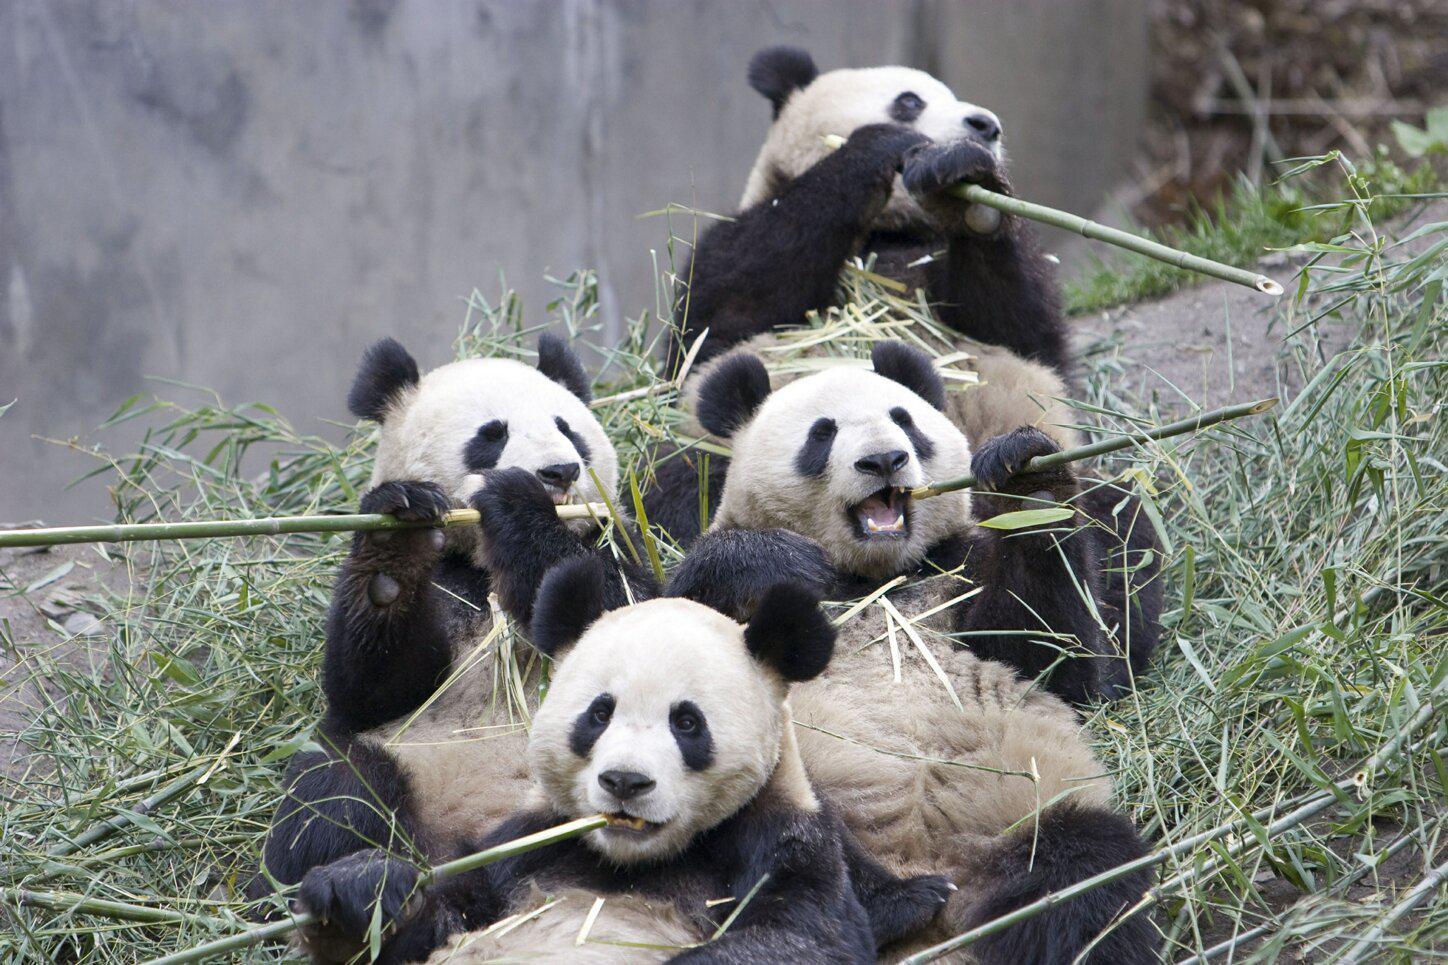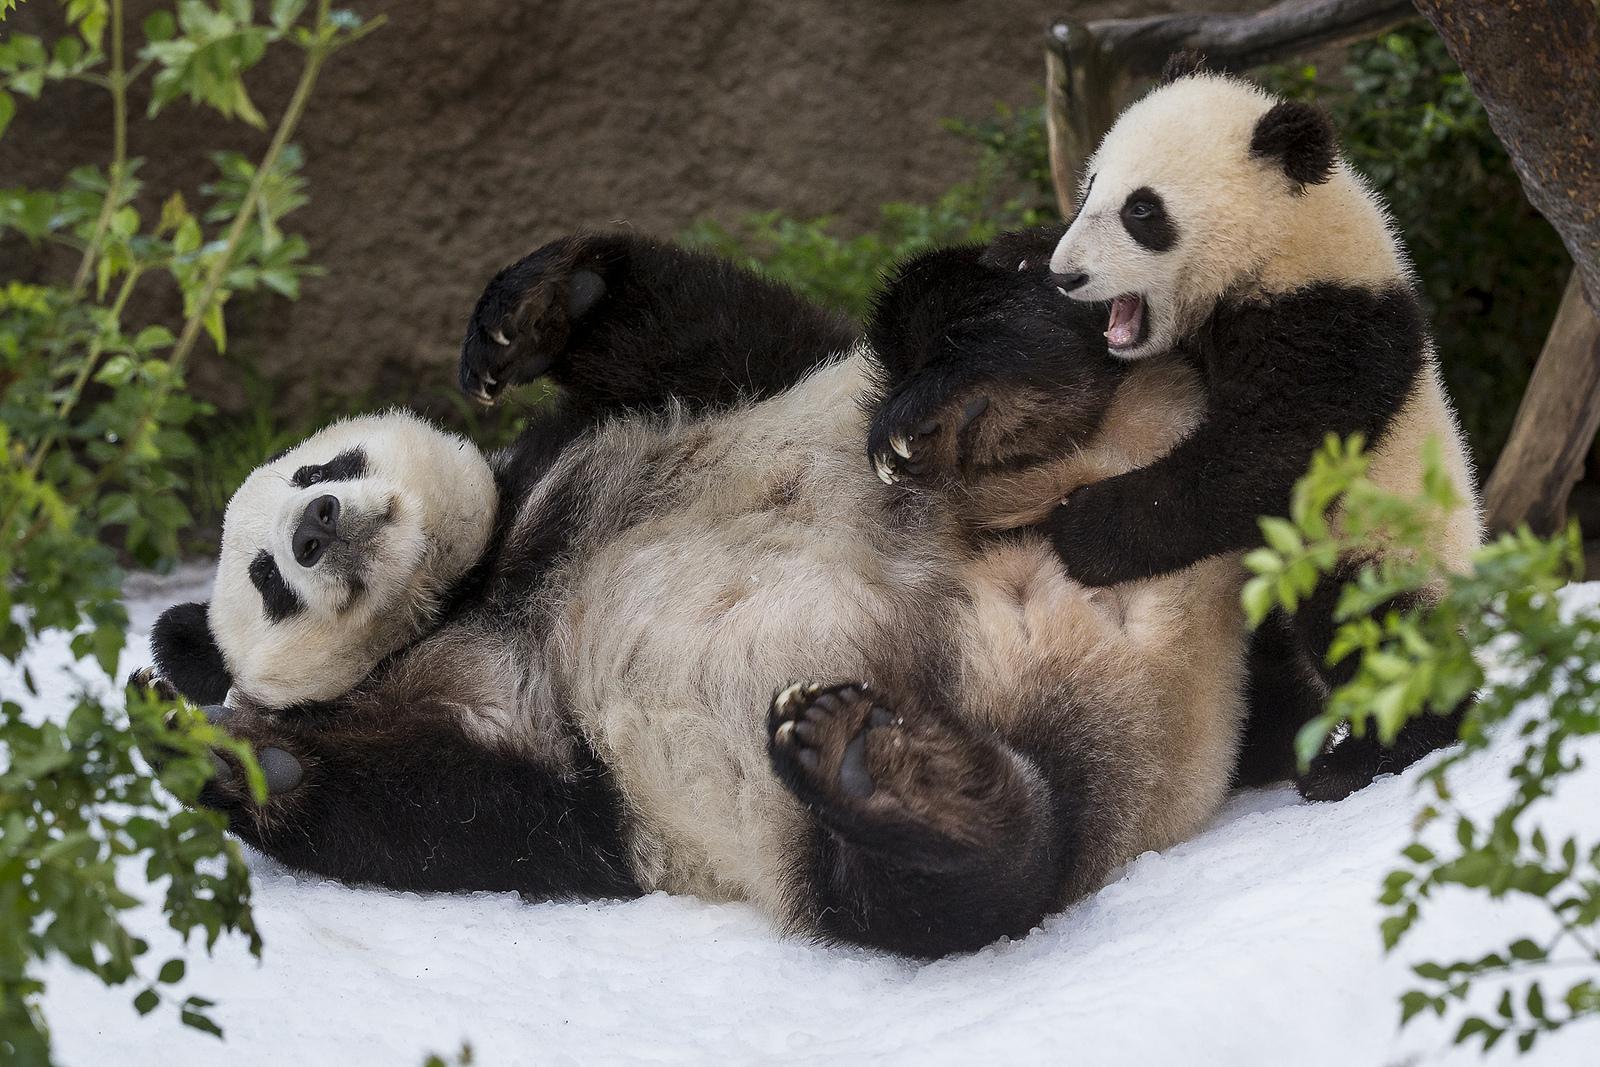The first image is the image on the left, the second image is the image on the right. Evaluate the accuracy of this statement regarding the images: "Some pandas are in the snow.". Is it true? Answer yes or no. Yes. The first image is the image on the left, the second image is the image on the right. Examine the images to the left and right. Is the description "There is at least one image where a single bear is animal is sitting alone." accurate? Answer yes or no. No. 